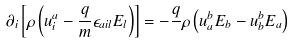Convert formula to latex. <formula><loc_0><loc_0><loc_500><loc_500>\partial _ { i } \left [ \rho \left ( u ^ { a } _ { i } - \frac { q } { m } \epsilon _ { a i l } E _ { l } \right ) \right ] = - \frac { q } { } \rho \left ( u ^ { b } _ { a } E _ { b } - u ^ { b } _ { b } E _ { a } \right )</formula> 